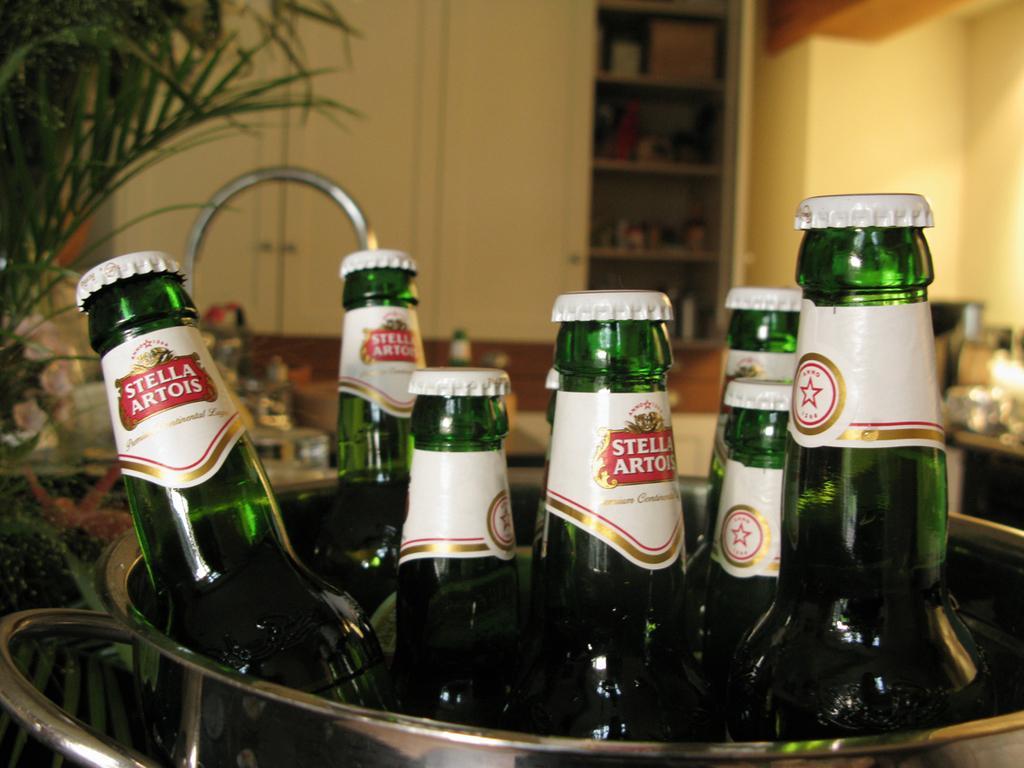Can you describe this image briefly? In this picture we can see some bottles in the bowl. On the background there is a wall. And this is rack. 